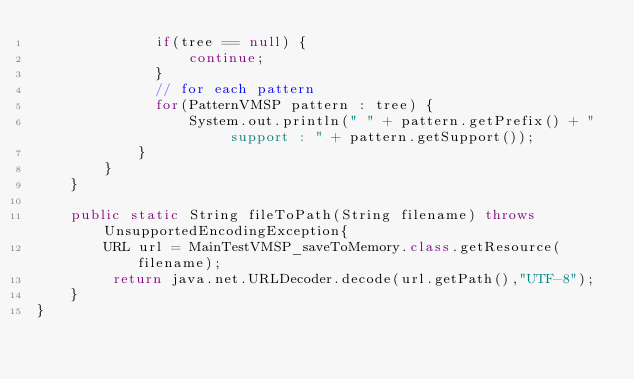Convert code to text. <code><loc_0><loc_0><loc_500><loc_500><_Java_>	    	  if(tree == null) {
	    		  continue;
	    	  }
	    	  // for each pattern
	    	  for(PatternVMSP pattern : tree) {
	    		  System.out.println(" " + pattern.getPrefix() + "  support : " + pattern.getSupport());
	  		}
		}
	}
	
	public static String fileToPath(String filename) throws UnsupportedEncodingException{
		URL url = MainTestVMSP_saveToMemory.class.getResource(filename);
		 return java.net.URLDecoder.decode(url.getPath(),"UTF-8");
	}
}</code> 